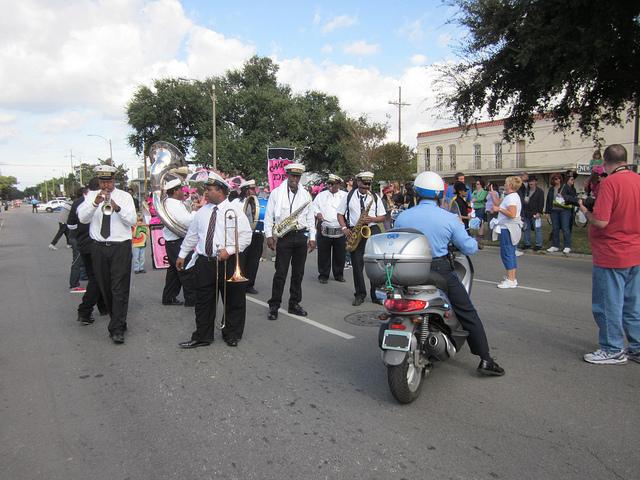What are the men holding in their hands?
Short answer required. Instruments. Is this a parade?
Give a very brief answer. Yes. How many bikes are there?
Answer briefly. 1. What are people with instruments doing in the middle of the street?
Give a very brief answer. Parade. Will many people watch the parade?
Write a very short answer. Yes. Is there a man sitting on a bench?
Keep it brief. No. Is the motorcycle on the road?
Answer briefly. Yes. 